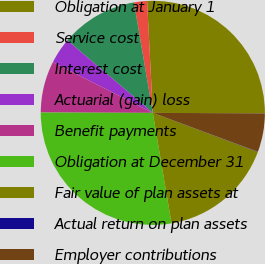Convert chart. <chart><loc_0><loc_0><loc_500><loc_500><pie_chart><fcel>Obligation at January 1<fcel>Service cost<fcel>Interest cost<fcel>Actuarial (gain) loss<fcel>Benefit payments<fcel>Obligation at December 31<fcel>Fair value of plan assets at<fcel>Actual return on plan assets<fcel>Employer contributions<nl><fcel>25.88%<fcel>1.88%<fcel>11.11%<fcel>3.73%<fcel>7.42%<fcel>27.72%<fcel>16.65%<fcel>0.04%<fcel>5.57%<nl></chart> 